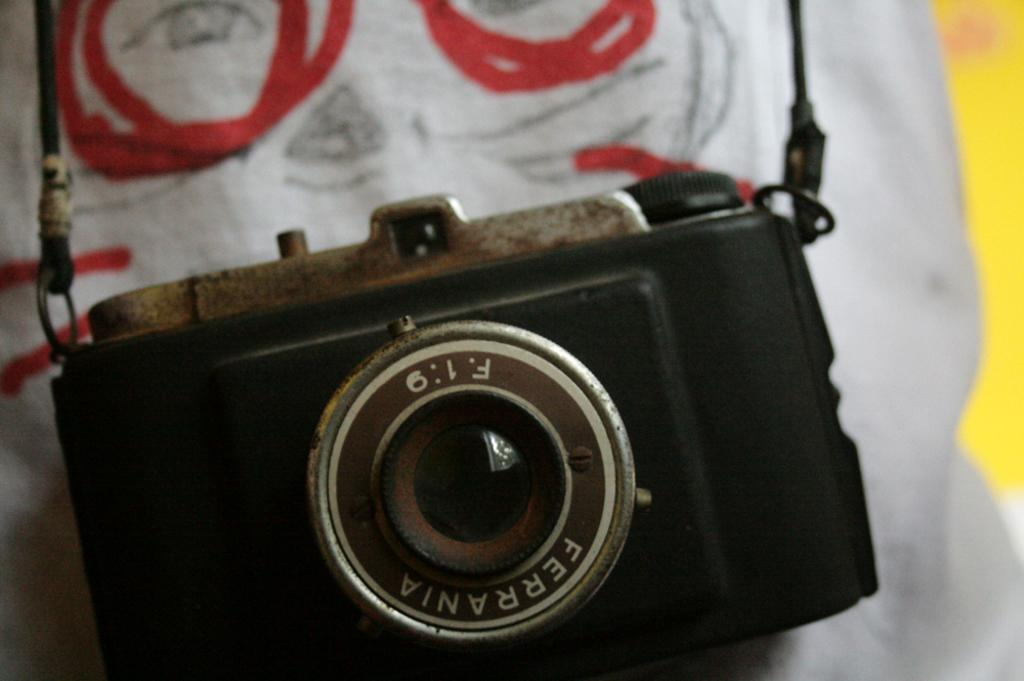What object is the main subject of the image? There is a camera in the image. What is the color of the camera? The camera is black in color. Where is the camera placed in the image? The camera is on a white surface. How many legs does the tent have in the image? There is no tent present in the image, so it is not possible to determine the number of legs it might have. 